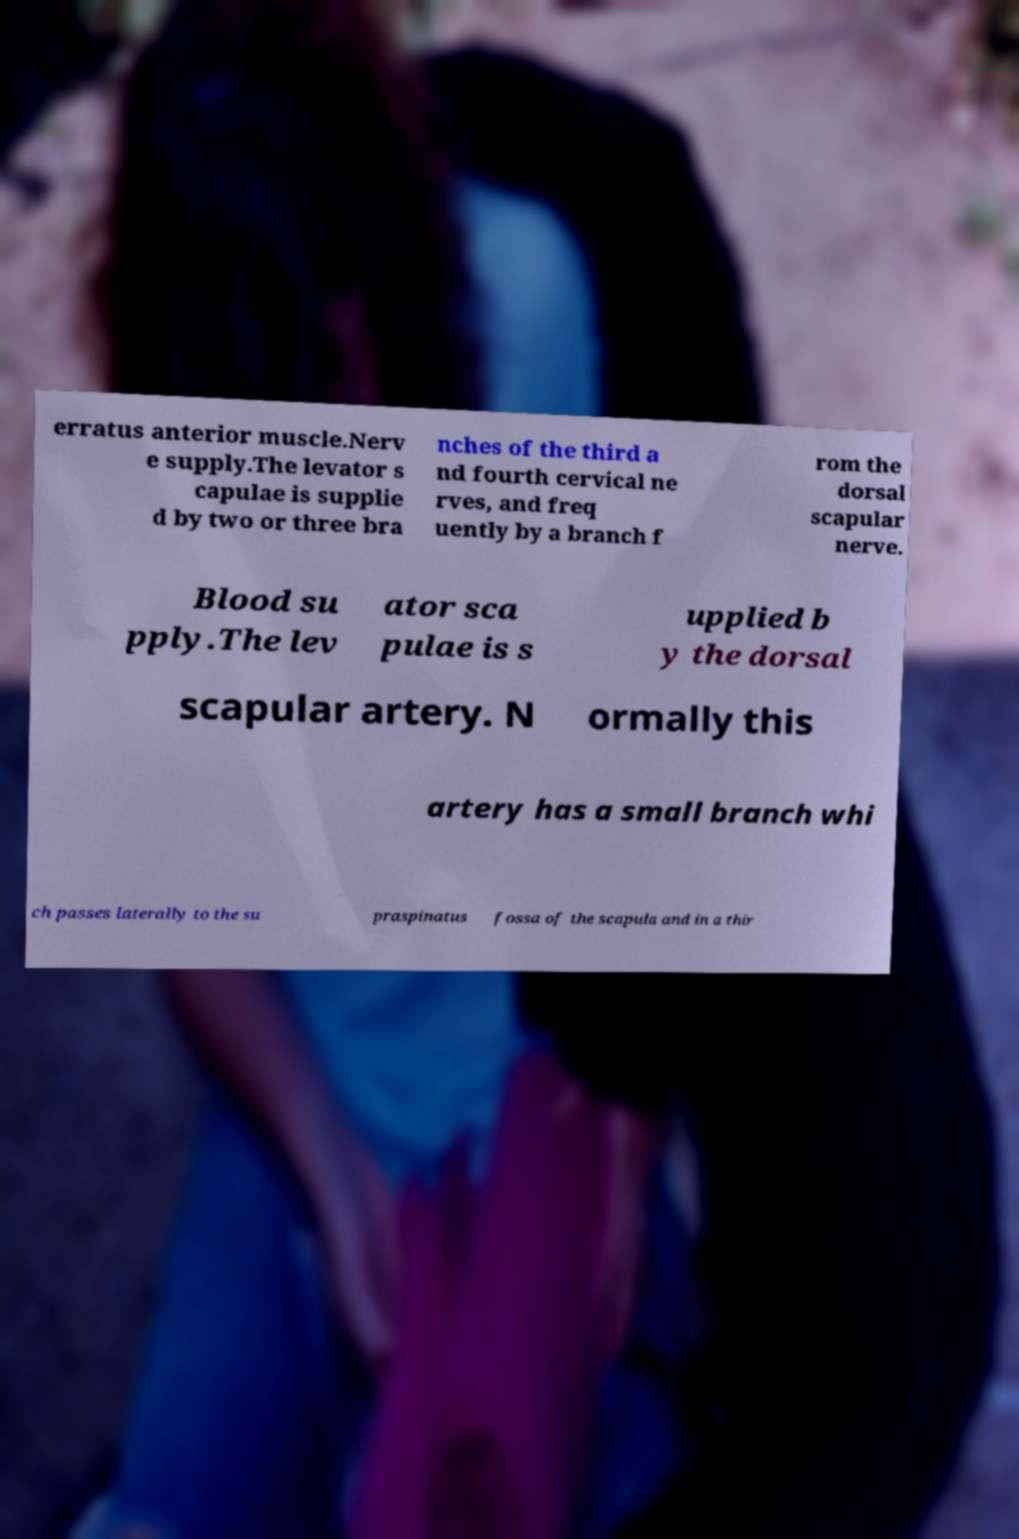What messages or text are displayed in this image? I need them in a readable, typed format. erratus anterior muscle.Nerv e supply.The levator s capulae is supplie d by two or three bra nches of the third a nd fourth cervical ne rves, and freq uently by a branch f rom the dorsal scapular nerve. Blood su pply.The lev ator sca pulae is s upplied b y the dorsal scapular artery. N ormally this artery has a small branch whi ch passes laterally to the su praspinatus fossa of the scapula and in a thir 